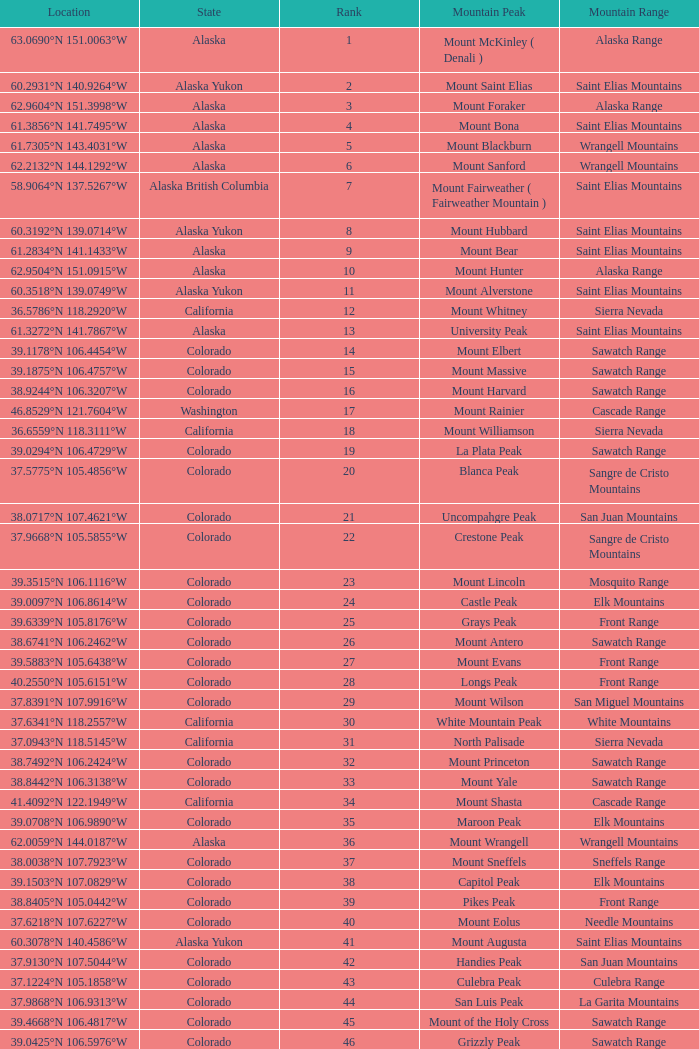What is the rank when the state is colorado and the location is 37.7859°n 107.7039°w? 83.0. 